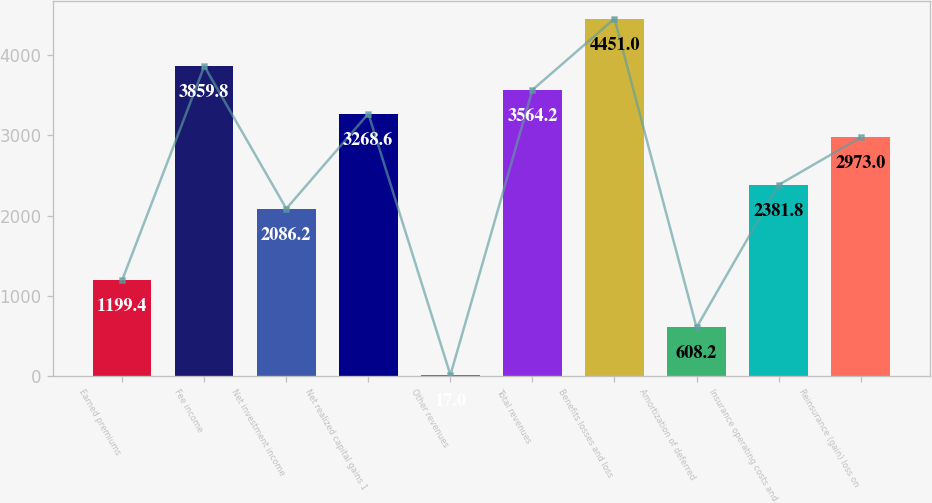Convert chart. <chart><loc_0><loc_0><loc_500><loc_500><bar_chart><fcel>Earned premiums<fcel>Fee income<fcel>Net investment income<fcel>Net realized capital gains 1<fcel>Other revenues<fcel>Total revenues<fcel>Benefits losses and loss<fcel>Amortization of deferred<fcel>Insurance operating costs and<fcel>Reinsurance (gain) loss on<nl><fcel>1199.4<fcel>3859.8<fcel>2086.2<fcel>3268.6<fcel>17<fcel>3564.2<fcel>4451<fcel>608.2<fcel>2381.8<fcel>2973<nl></chart> 